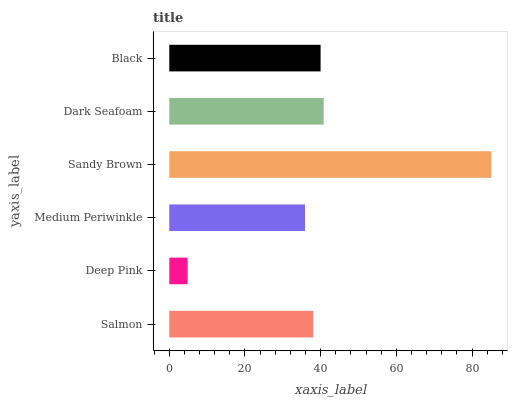Is Deep Pink the minimum?
Answer yes or no. Yes. Is Sandy Brown the maximum?
Answer yes or no. Yes. Is Medium Periwinkle the minimum?
Answer yes or no. No. Is Medium Periwinkle the maximum?
Answer yes or no. No. Is Medium Periwinkle greater than Deep Pink?
Answer yes or no. Yes. Is Deep Pink less than Medium Periwinkle?
Answer yes or no. Yes. Is Deep Pink greater than Medium Periwinkle?
Answer yes or no. No. Is Medium Periwinkle less than Deep Pink?
Answer yes or no. No. Is Black the high median?
Answer yes or no. Yes. Is Salmon the low median?
Answer yes or no. Yes. Is Sandy Brown the high median?
Answer yes or no. No. Is Sandy Brown the low median?
Answer yes or no. No. 